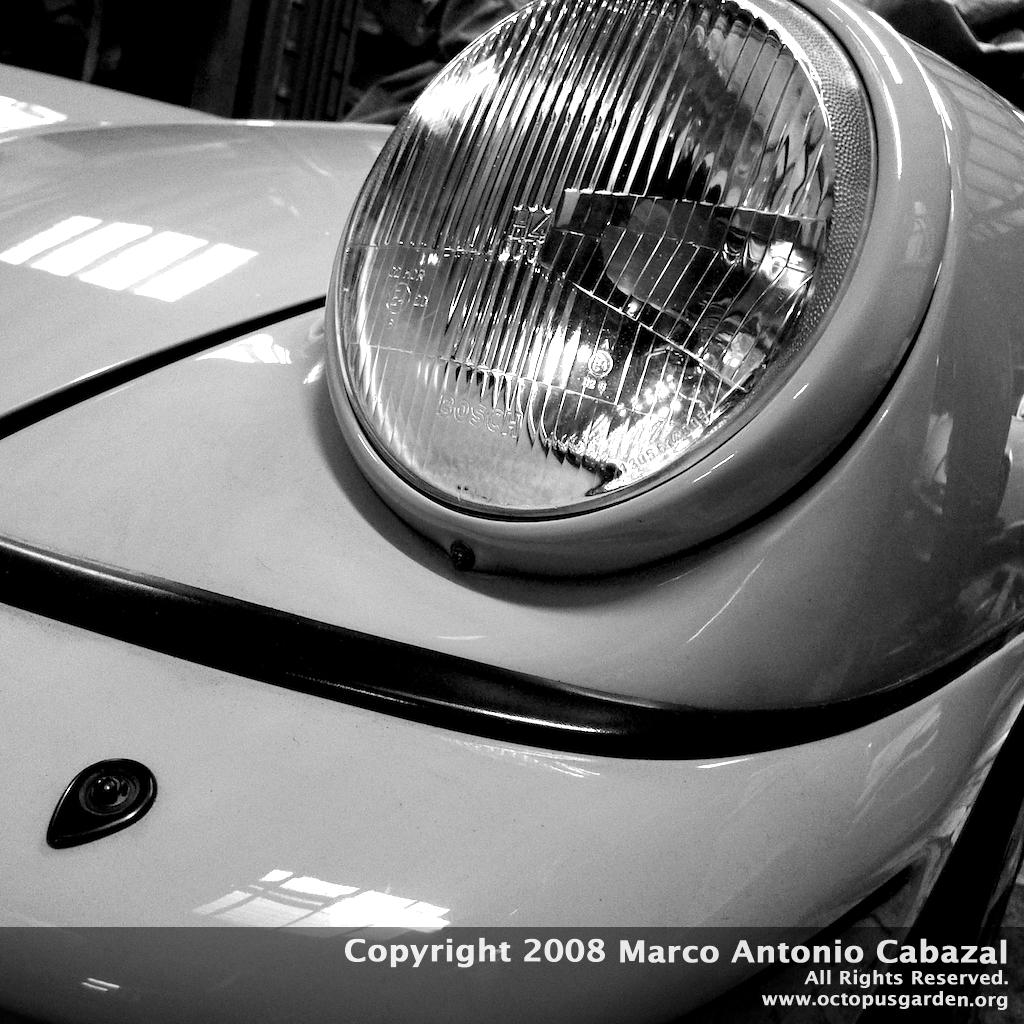What is the main subject in the foreground of the image? There is a vehicle in the foreground of the image. Can you describe anything in the background of the image? There appears to be a person in the background of the image. What additional information can be found at the bottom of the image? There is text visible at the bottom of the image. What type of test is being conducted on the wire in the image? There is no wire present in the image, so no test can be conducted on it. 